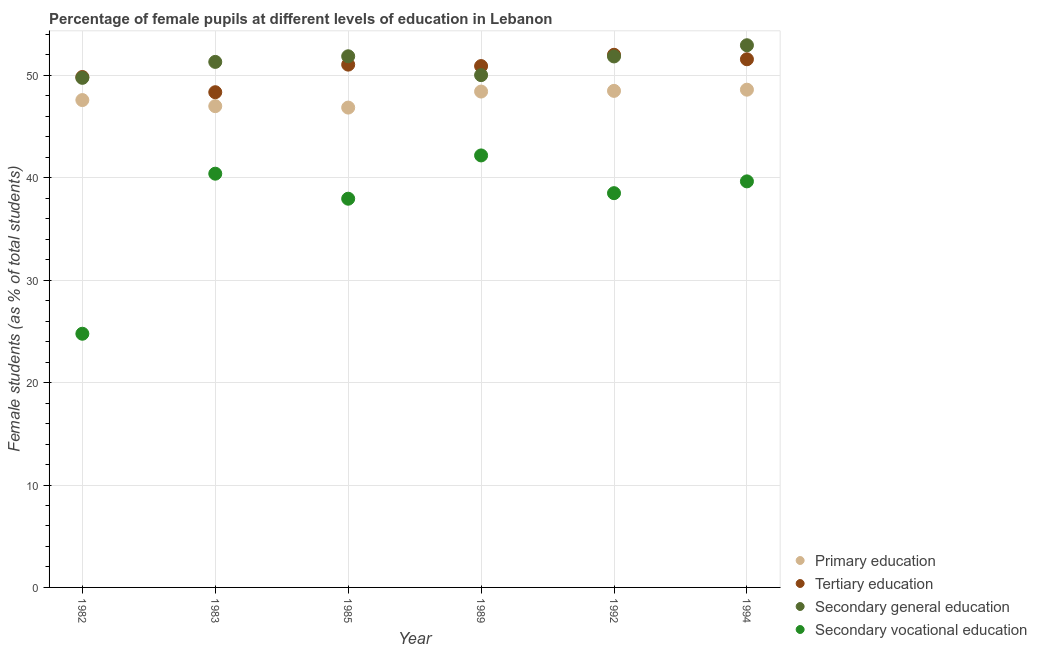What is the percentage of female students in tertiary education in 1992?
Give a very brief answer. 52.01. Across all years, what is the maximum percentage of female students in secondary education?
Your answer should be compact. 52.94. Across all years, what is the minimum percentage of female students in tertiary education?
Give a very brief answer. 48.36. What is the total percentage of female students in secondary vocational education in the graph?
Your answer should be compact. 223.47. What is the difference between the percentage of female students in primary education in 1985 and that in 1992?
Your answer should be very brief. -1.63. What is the difference between the percentage of female students in secondary education in 1983 and the percentage of female students in tertiary education in 1994?
Provide a short and direct response. -0.26. What is the average percentage of female students in tertiary education per year?
Offer a terse response. 50.63. In the year 1992, what is the difference between the percentage of female students in primary education and percentage of female students in secondary education?
Your answer should be compact. -3.36. In how many years, is the percentage of female students in secondary vocational education greater than 22 %?
Give a very brief answer. 6. What is the ratio of the percentage of female students in primary education in 1985 to that in 1989?
Offer a very short reply. 0.97. Is the percentage of female students in tertiary education in 1983 less than that in 1992?
Keep it short and to the point. Yes. Is the difference between the percentage of female students in secondary vocational education in 1983 and 1985 greater than the difference between the percentage of female students in primary education in 1983 and 1985?
Make the answer very short. Yes. What is the difference between the highest and the second highest percentage of female students in secondary education?
Give a very brief answer. 1.08. What is the difference between the highest and the lowest percentage of female students in tertiary education?
Ensure brevity in your answer.  3.66. In how many years, is the percentage of female students in secondary vocational education greater than the average percentage of female students in secondary vocational education taken over all years?
Offer a very short reply. 5. Is it the case that in every year, the sum of the percentage of female students in tertiary education and percentage of female students in secondary vocational education is greater than the sum of percentage of female students in secondary education and percentage of female students in primary education?
Offer a terse response. No. How many dotlines are there?
Keep it short and to the point. 4. How many years are there in the graph?
Provide a short and direct response. 6. Are the values on the major ticks of Y-axis written in scientific E-notation?
Provide a succinct answer. No. Does the graph contain any zero values?
Keep it short and to the point. No. Does the graph contain grids?
Make the answer very short. Yes. Where does the legend appear in the graph?
Your answer should be very brief. Bottom right. What is the title of the graph?
Provide a short and direct response. Percentage of female pupils at different levels of education in Lebanon. What is the label or title of the X-axis?
Make the answer very short. Year. What is the label or title of the Y-axis?
Provide a short and direct response. Female students (as % of total students). What is the Female students (as % of total students) of Primary education in 1982?
Ensure brevity in your answer.  47.59. What is the Female students (as % of total students) in Tertiary education in 1982?
Provide a succinct answer. 49.84. What is the Female students (as % of total students) in Secondary general education in 1982?
Ensure brevity in your answer.  49.76. What is the Female students (as % of total students) of Secondary vocational education in 1982?
Offer a very short reply. 24.77. What is the Female students (as % of total students) of Primary education in 1983?
Provide a succinct answer. 47. What is the Female students (as % of total students) in Tertiary education in 1983?
Keep it short and to the point. 48.36. What is the Female students (as % of total students) in Secondary general education in 1983?
Offer a terse response. 51.32. What is the Female students (as % of total students) of Secondary vocational education in 1983?
Make the answer very short. 40.4. What is the Female students (as % of total students) in Primary education in 1985?
Provide a succinct answer. 46.86. What is the Female students (as % of total students) of Tertiary education in 1985?
Give a very brief answer. 51.05. What is the Female students (as % of total students) in Secondary general education in 1985?
Offer a very short reply. 51.87. What is the Female students (as % of total students) in Secondary vocational education in 1985?
Keep it short and to the point. 37.96. What is the Female students (as % of total students) of Primary education in 1989?
Your answer should be compact. 48.42. What is the Female students (as % of total students) in Tertiary education in 1989?
Provide a short and direct response. 50.91. What is the Female students (as % of total students) of Secondary general education in 1989?
Make the answer very short. 50.03. What is the Female students (as % of total students) of Secondary vocational education in 1989?
Ensure brevity in your answer.  42.18. What is the Female students (as % of total students) in Primary education in 1992?
Give a very brief answer. 48.49. What is the Female students (as % of total students) of Tertiary education in 1992?
Ensure brevity in your answer.  52.01. What is the Female students (as % of total students) of Secondary general education in 1992?
Provide a short and direct response. 51.85. What is the Female students (as % of total students) in Secondary vocational education in 1992?
Offer a very short reply. 38.5. What is the Female students (as % of total students) of Primary education in 1994?
Keep it short and to the point. 48.6. What is the Female students (as % of total students) of Tertiary education in 1994?
Provide a succinct answer. 51.58. What is the Female students (as % of total students) of Secondary general education in 1994?
Your response must be concise. 52.94. What is the Female students (as % of total students) of Secondary vocational education in 1994?
Offer a very short reply. 39.65. Across all years, what is the maximum Female students (as % of total students) of Primary education?
Offer a very short reply. 48.6. Across all years, what is the maximum Female students (as % of total students) of Tertiary education?
Keep it short and to the point. 52.01. Across all years, what is the maximum Female students (as % of total students) in Secondary general education?
Provide a short and direct response. 52.94. Across all years, what is the maximum Female students (as % of total students) of Secondary vocational education?
Provide a short and direct response. 42.18. Across all years, what is the minimum Female students (as % of total students) of Primary education?
Offer a very short reply. 46.86. Across all years, what is the minimum Female students (as % of total students) of Tertiary education?
Your answer should be very brief. 48.36. Across all years, what is the minimum Female students (as % of total students) in Secondary general education?
Make the answer very short. 49.76. Across all years, what is the minimum Female students (as % of total students) in Secondary vocational education?
Your response must be concise. 24.77. What is the total Female students (as % of total students) of Primary education in the graph?
Your answer should be compact. 286.96. What is the total Female students (as % of total students) in Tertiary education in the graph?
Offer a very short reply. 303.75. What is the total Female students (as % of total students) of Secondary general education in the graph?
Provide a short and direct response. 307.77. What is the total Female students (as % of total students) in Secondary vocational education in the graph?
Make the answer very short. 223.47. What is the difference between the Female students (as % of total students) in Primary education in 1982 and that in 1983?
Keep it short and to the point. 0.59. What is the difference between the Female students (as % of total students) of Tertiary education in 1982 and that in 1983?
Provide a short and direct response. 1.49. What is the difference between the Female students (as % of total students) in Secondary general education in 1982 and that in 1983?
Provide a short and direct response. -1.56. What is the difference between the Female students (as % of total students) of Secondary vocational education in 1982 and that in 1983?
Give a very brief answer. -15.63. What is the difference between the Female students (as % of total students) of Primary education in 1982 and that in 1985?
Give a very brief answer. 0.73. What is the difference between the Female students (as % of total students) in Tertiary education in 1982 and that in 1985?
Offer a very short reply. -1.21. What is the difference between the Female students (as % of total students) in Secondary general education in 1982 and that in 1985?
Offer a terse response. -2.11. What is the difference between the Female students (as % of total students) in Secondary vocational education in 1982 and that in 1985?
Ensure brevity in your answer.  -13.19. What is the difference between the Female students (as % of total students) in Primary education in 1982 and that in 1989?
Keep it short and to the point. -0.83. What is the difference between the Female students (as % of total students) of Tertiary education in 1982 and that in 1989?
Provide a short and direct response. -1.07. What is the difference between the Female students (as % of total students) in Secondary general education in 1982 and that in 1989?
Keep it short and to the point. -0.26. What is the difference between the Female students (as % of total students) in Secondary vocational education in 1982 and that in 1989?
Make the answer very short. -17.41. What is the difference between the Female students (as % of total students) in Primary education in 1982 and that in 1992?
Offer a terse response. -0.9. What is the difference between the Female students (as % of total students) of Tertiary education in 1982 and that in 1992?
Make the answer very short. -2.17. What is the difference between the Female students (as % of total students) in Secondary general education in 1982 and that in 1992?
Keep it short and to the point. -2.09. What is the difference between the Female students (as % of total students) of Secondary vocational education in 1982 and that in 1992?
Provide a succinct answer. -13.73. What is the difference between the Female students (as % of total students) in Primary education in 1982 and that in 1994?
Ensure brevity in your answer.  -1.01. What is the difference between the Female students (as % of total students) in Tertiary education in 1982 and that in 1994?
Your response must be concise. -1.73. What is the difference between the Female students (as % of total students) of Secondary general education in 1982 and that in 1994?
Provide a succinct answer. -3.18. What is the difference between the Female students (as % of total students) in Secondary vocational education in 1982 and that in 1994?
Your answer should be very brief. -14.88. What is the difference between the Female students (as % of total students) of Primary education in 1983 and that in 1985?
Your answer should be very brief. 0.14. What is the difference between the Female students (as % of total students) of Tertiary education in 1983 and that in 1985?
Provide a short and direct response. -2.69. What is the difference between the Female students (as % of total students) in Secondary general education in 1983 and that in 1985?
Provide a short and direct response. -0.55. What is the difference between the Female students (as % of total students) in Secondary vocational education in 1983 and that in 1985?
Your response must be concise. 2.44. What is the difference between the Female students (as % of total students) of Primary education in 1983 and that in 1989?
Offer a terse response. -1.43. What is the difference between the Female students (as % of total students) of Tertiary education in 1983 and that in 1989?
Offer a terse response. -2.55. What is the difference between the Female students (as % of total students) in Secondary general education in 1983 and that in 1989?
Make the answer very short. 1.29. What is the difference between the Female students (as % of total students) in Secondary vocational education in 1983 and that in 1989?
Make the answer very short. -1.78. What is the difference between the Female students (as % of total students) in Primary education in 1983 and that in 1992?
Make the answer very short. -1.49. What is the difference between the Female students (as % of total students) of Tertiary education in 1983 and that in 1992?
Give a very brief answer. -3.66. What is the difference between the Female students (as % of total students) of Secondary general education in 1983 and that in 1992?
Provide a short and direct response. -0.53. What is the difference between the Female students (as % of total students) in Secondary vocational education in 1983 and that in 1992?
Provide a short and direct response. 1.9. What is the difference between the Female students (as % of total students) of Primary education in 1983 and that in 1994?
Offer a terse response. -1.61. What is the difference between the Female students (as % of total students) in Tertiary education in 1983 and that in 1994?
Make the answer very short. -3.22. What is the difference between the Female students (as % of total students) in Secondary general education in 1983 and that in 1994?
Give a very brief answer. -1.63. What is the difference between the Female students (as % of total students) of Secondary vocational education in 1983 and that in 1994?
Your response must be concise. 0.75. What is the difference between the Female students (as % of total students) in Primary education in 1985 and that in 1989?
Your answer should be compact. -1.57. What is the difference between the Female students (as % of total students) of Tertiary education in 1985 and that in 1989?
Offer a terse response. 0.14. What is the difference between the Female students (as % of total students) of Secondary general education in 1985 and that in 1989?
Provide a succinct answer. 1.84. What is the difference between the Female students (as % of total students) of Secondary vocational education in 1985 and that in 1989?
Provide a short and direct response. -4.23. What is the difference between the Female students (as % of total students) of Primary education in 1985 and that in 1992?
Offer a very short reply. -1.63. What is the difference between the Female students (as % of total students) of Tertiary education in 1985 and that in 1992?
Offer a very short reply. -0.96. What is the difference between the Female students (as % of total students) of Secondary general education in 1985 and that in 1992?
Keep it short and to the point. 0.02. What is the difference between the Female students (as % of total students) in Secondary vocational education in 1985 and that in 1992?
Ensure brevity in your answer.  -0.54. What is the difference between the Female students (as % of total students) of Primary education in 1985 and that in 1994?
Offer a terse response. -1.75. What is the difference between the Female students (as % of total students) of Tertiary education in 1985 and that in 1994?
Provide a succinct answer. -0.52. What is the difference between the Female students (as % of total students) of Secondary general education in 1985 and that in 1994?
Your response must be concise. -1.08. What is the difference between the Female students (as % of total students) of Secondary vocational education in 1985 and that in 1994?
Give a very brief answer. -1.69. What is the difference between the Female students (as % of total students) of Primary education in 1989 and that in 1992?
Provide a short and direct response. -0.07. What is the difference between the Female students (as % of total students) in Tertiary education in 1989 and that in 1992?
Make the answer very short. -1.1. What is the difference between the Female students (as % of total students) of Secondary general education in 1989 and that in 1992?
Your response must be concise. -1.83. What is the difference between the Female students (as % of total students) of Secondary vocational education in 1989 and that in 1992?
Your response must be concise. 3.69. What is the difference between the Female students (as % of total students) in Primary education in 1989 and that in 1994?
Provide a short and direct response. -0.18. What is the difference between the Female students (as % of total students) in Tertiary education in 1989 and that in 1994?
Provide a short and direct response. -0.67. What is the difference between the Female students (as % of total students) of Secondary general education in 1989 and that in 1994?
Provide a succinct answer. -2.92. What is the difference between the Female students (as % of total students) of Secondary vocational education in 1989 and that in 1994?
Make the answer very short. 2.53. What is the difference between the Female students (as % of total students) in Primary education in 1992 and that in 1994?
Keep it short and to the point. -0.12. What is the difference between the Female students (as % of total students) of Tertiary education in 1992 and that in 1994?
Provide a succinct answer. 0.44. What is the difference between the Female students (as % of total students) of Secondary general education in 1992 and that in 1994?
Your answer should be very brief. -1.09. What is the difference between the Female students (as % of total students) of Secondary vocational education in 1992 and that in 1994?
Offer a terse response. -1.15. What is the difference between the Female students (as % of total students) in Primary education in 1982 and the Female students (as % of total students) in Tertiary education in 1983?
Your answer should be very brief. -0.77. What is the difference between the Female students (as % of total students) in Primary education in 1982 and the Female students (as % of total students) in Secondary general education in 1983?
Make the answer very short. -3.73. What is the difference between the Female students (as % of total students) of Primary education in 1982 and the Female students (as % of total students) of Secondary vocational education in 1983?
Your response must be concise. 7.19. What is the difference between the Female students (as % of total students) in Tertiary education in 1982 and the Female students (as % of total students) in Secondary general education in 1983?
Your answer should be very brief. -1.47. What is the difference between the Female students (as % of total students) in Tertiary education in 1982 and the Female students (as % of total students) in Secondary vocational education in 1983?
Provide a short and direct response. 9.44. What is the difference between the Female students (as % of total students) in Secondary general education in 1982 and the Female students (as % of total students) in Secondary vocational education in 1983?
Offer a terse response. 9.36. What is the difference between the Female students (as % of total students) of Primary education in 1982 and the Female students (as % of total students) of Tertiary education in 1985?
Your response must be concise. -3.46. What is the difference between the Female students (as % of total students) of Primary education in 1982 and the Female students (as % of total students) of Secondary general education in 1985?
Your answer should be very brief. -4.28. What is the difference between the Female students (as % of total students) of Primary education in 1982 and the Female students (as % of total students) of Secondary vocational education in 1985?
Give a very brief answer. 9.63. What is the difference between the Female students (as % of total students) in Tertiary education in 1982 and the Female students (as % of total students) in Secondary general education in 1985?
Your response must be concise. -2.02. What is the difference between the Female students (as % of total students) in Tertiary education in 1982 and the Female students (as % of total students) in Secondary vocational education in 1985?
Keep it short and to the point. 11.89. What is the difference between the Female students (as % of total students) of Secondary general education in 1982 and the Female students (as % of total students) of Secondary vocational education in 1985?
Your answer should be very brief. 11.8. What is the difference between the Female students (as % of total students) in Primary education in 1982 and the Female students (as % of total students) in Tertiary education in 1989?
Your response must be concise. -3.32. What is the difference between the Female students (as % of total students) of Primary education in 1982 and the Female students (as % of total students) of Secondary general education in 1989?
Make the answer very short. -2.43. What is the difference between the Female students (as % of total students) of Primary education in 1982 and the Female students (as % of total students) of Secondary vocational education in 1989?
Offer a terse response. 5.41. What is the difference between the Female students (as % of total students) of Tertiary education in 1982 and the Female students (as % of total students) of Secondary general education in 1989?
Your answer should be very brief. -0.18. What is the difference between the Female students (as % of total students) in Tertiary education in 1982 and the Female students (as % of total students) in Secondary vocational education in 1989?
Make the answer very short. 7.66. What is the difference between the Female students (as % of total students) in Secondary general education in 1982 and the Female students (as % of total students) in Secondary vocational education in 1989?
Make the answer very short. 7.58. What is the difference between the Female students (as % of total students) of Primary education in 1982 and the Female students (as % of total students) of Tertiary education in 1992?
Provide a succinct answer. -4.42. What is the difference between the Female students (as % of total students) in Primary education in 1982 and the Female students (as % of total students) in Secondary general education in 1992?
Keep it short and to the point. -4.26. What is the difference between the Female students (as % of total students) in Primary education in 1982 and the Female students (as % of total students) in Secondary vocational education in 1992?
Make the answer very short. 9.09. What is the difference between the Female students (as % of total students) in Tertiary education in 1982 and the Female students (as % of total students) in Secondary general education in 1992?
Ensure brevity in your answer.  -2.01. What is the difference between the Female students (as % of total students) in Tertiary education in 1982 and the Female students (as % of total students) in Secondary vocational education in 1992?
Provide a succinct answer. 11.34. What is the difference between the Female students (as % of total students) of Secondary general education in 1982 and the Female students (as % of total students) of Secondary vocational education in 1992?
Ensure brevity in your answer.  11.26. What is the difference between the Female students (as % of total students) of Primary education in 1982 and the Female students (as % of total students) of Tertiary education in 1994?
Your answer should be compact. -3.99. What is the difference between the Female students (as % of total students) of Primary education in 1982 and the Female students (as % of total students) of Secondary general education in 1994?
Ensure brevity in your answer.  -5.35. What is the difference between the Female students (as % of total students) in Primary education in 1982 and the Female students (as % of total students) in Secondary vocational education in 1994?
Make the answer very short. 7.94. What is the difference between the Female students (as % of total students) in Tertiary education in 1982 and the Female students (as % of total students) in Secondary general education in 1994?
Provide a succinct answer. -3.1. What is the difference between the Female students (as % of total students) in Tertiary education in 1982 and the Female students (as % of total students) in Secondary vocational education in 1994?
Keep it short and to the point. 10.19. What is the difference between the Female students (as % of total students) in Secondary general education in 1982 and the Female students (as % of total students) in Secondary vocational education in 1994?
Provide a short and direct response. 10.11. What is the difference between the Female students (as % of total students) of Primary education in 1983 and the Female students (as % of total students) of Tertiary education in 1985?
Ensure brevity in your answer.  -4.06. What is the difference between the Female students (as % of total students) of Primary education in 1983 and the Female students (as % of total students) of Secondary general education in 1985?
Provide a short and direct response. -4.87. What is the difference between the Female students (as % of total students) of Primary education in 1983 and the Female students (as % of total students) of Secondary vocational education in 1985?
Ensure brevity in your answer.  9.04. What is the difference between the Female students (as % of total students) of Tertiary education in 1983 and the Female students (as % of total students) of Secondary general education in 1985?
Provide a short and direct response. -3.51. What is the difference between the Female students (as % of total students) in Tertiary education in 1983 and the Female students (as % of total students) in Secondary vocational education in 1985?
Offer a terse response. 10.4. What is the difference between the Female students (as % of total students) in Secondary general education in 1983 and the Female students (as % of total students) in Secondary vocational education in 1985?
Provide a succinct answer. 13.36. What is the difference between the Female students (as % of total students) of Primary education in 1983 and the Female students (as % of total students) of Tertiary education in 1989?
Offer a very short reply. -3.91. What is the difference between the Female students (as % of total students) of Primary education in 1983 and the Female students (as % of total students) of Secondary general education in 1989?
Provide a short and direct response. -3.03. What is the difference between the Female students (as % of total students) in Primary education in 1983 and the Female students (as % of total students) in Secondary vocational education in 1989?
Your response must be concise. 4.81. What is the difference between the Female students (as % of total students) in Tertiary education in 1983 and the Female students (as % of total students) in Secondary general education in 1989?
Provide a short and direct response. -1.67. What is the difference between the Female students (as % of total students) of Tertiary education in 1983 and the Female students (as % of total students) of Secondary vocational education in 1989?
Make the answer very short. 6.17. What is the difference between the Female students (as % of total students) of Secondary general education in 1983 and the Female students (as % of total students) of Secondary vocational education in 1989?
Offer a terse response. 9.13. What is the difference between the Female students (as % of total students) of Primary education in 1983 and the Female students (as % of total students) of Tertiary education in 1992?
Your answer should be very brief. -5.02. What is the difference between the Female students (as % of total students) of Primary education in 1983 and the Female students (as % of total students) of Secondary general education in 1992?
Offer a terse response. -4.85. What is the difference between the Female students (as % of total students) in Primary education in 1983 and the Female students (as % of total students) in Secondary vocational education in 1992?
Keep it short and to the point. 8.5. What is the difference between the Female students (as % of total students) in Tertiary education in 1983 and the Female students (as % of total students) in Secondary general education in 1992?
Offer a very short reply. -3.49. What is the difference between the Female students (as % of total students) of Tertiary education in 1983 and the Female students (as % of total students) of Secondary vocational education in 1992?
Give a very brief answer. 9.86. What is the difference between the Female students (as % of total students) of Secondary general education in 1983 and the Female students (as % of total students) of Secondary vocational education in 1992?
Keep it short and to the point. 12.82. What is the difference between the Female students (as % of total students) of Primary education in 1983 and the Female students (as % of total students) of Tertiary education in 1994?
Provide a short and direct response. -4.58. What is the difference between the Female students (as % of total students) of Primary education in 1983 and the Female students (as % of total students) of Secondary general education in 1994?
Ensure brevity in your answer.  -5.95. What is the difference between the Female students (as % of total students) in Primary education in 1983 and the Female students (as % of total students) in Secondary vocational education in 1994?
Provide a succinct answer. 7.34. What is the difference between the Female students (as % of total students) in Tertiary education in 1983 and the Female students (as % of total students) in Secondary general education in 1994?
Provide a short and direct response. -4.59. What is the difference between the Female students (as % of total students) of Tertiary education in 1983 and the Female students (as % of total students) of Secondary vocational education in 1994?
Offer a terse response. 8.71. What is the difference between the Female students (as % of total students) in Secondary general education in 1983 and the Female students (as % of total students) in Secondary vocational education in 1994?
Give a very brief answer. 11.67. What is the difference between the Female students (as % of total students) in Primary education in 1985 and the Female students (as % of total students) in Tertiary education in 1989?
Give a very brief answer. -4.05. What is the difference between the Female students (as % of total students) in Primary education in 1985 and the Female students (as % of total students) in Secondary general education in 1989?
Offer a terse response. -3.17. What is the difference between the Female students (as % of total students) in Primary education in 1985 and the Female students (as % of total students) in Secondary vocational education in 1989?
Give a very brief answer. 4.67. What is the difference between the Female students (as % of total students) in Tertiary education in 1985 and the Female students (as % of total students) in Secondary general education in 1989?
Give a very brief answer. 1.03. What is the difference between the Female students (as % of total students) in Tertiary education in 1985 and the Female students (as % of total students) in Secondary vocational education in 1989?
Provide a succinct answer. 8.87. What is the difference between the Female students (as % of total students) in Secondary general education in 1985 and the Female students (as % of total students) in Secondary vocational education in 1989?
Ensure brevity in your answer.  9.68. What is the difference between the Female students (as % of total students) in Primary education in 1985 and the Female students (as % of total students) in Tertiary education in 1992?
Your response must be concise. -5.16. What is the difference between the Female students (as % of total students) in Primary education in 1985 and the Female students (as % of total students) in Secondary general education in 1992?
Provide a succinct answer. -4.99. What is the difference between the Female students (as % of total students) of Primary education in 1985 and the Female students (as % of total students) of Secondary vocational education in 1992?
Give a very brief answer. 8.36. What is the difference between the Female students (as % of total students) of Tertiary education in 1985 and the Female students (as % of total students) of Secondary general education in 1992?
Your response must be concise. -0.8. What is the difference between the Female students (as % of total students) of Tertiary education in 1985 and the Female students (as % of total students) of Secondary vocational education in 1992?
Ensure brevity in your answer.  12.55. What is the difference between the Female students (as % of total students) in Secondary general education in 1985 and the Female students (as % of total students) in Secondary vocational education in 1992?
Your response must be concise. 13.37. What is the difference between the Female students (as % of total students) in Primary education in 1985 and the Female students (as % of total students) in Tertiary education in 1994?
Keep it short and to the point. -4.72. What is the difference between the Female students (as % of total students) in Primary education in 1985 and the Female students (as % of total students) in Secondary general education in 1994?
Provide a short and direct response. -6.09. What is the difference between the Female students (as % of total students) in Primary education in 1985 and the Female students (as % of total students) in Secondary vocational education in 1994?
Ensure brevity in your answer.  7.21. What is the difference between the Female students (as % of total students) in Tertiary education in 1985 and the Female students (as % of total students) in Secondary general education in 1994?
Your response must be concise. -1.89. What is the difference between the Female students (as % of total students) in Tertiary education in 1985 and the Female students (as % of total students) in Secondary vocational education in 1994?
Provide a succinct answer. 11.4. What is the difference between the Female students (as % of total students) in Secondary general education in 1985 and the Female students (as % of total students) in Secondary vocational education in 1994?
Ensure brevity in your answer.  12.22. What is the difference between the Female students (as % of total students) of Primary education in 1989 and the Female students (as % of total students) of Tertiary education in 1992?
Your answer should be very brief. -3.59. What is the difference between the Female students (as % of total students) in Primary education in 1989 and the Female students (as % of total students) in Secondary general education in 1992?
Offer a terse response. -3.43. What is the difference between the Female students (as % of total students) in Primary education in 1989 and the Female students (as % of total students) in Secondary vocational education in 1992?
Give a very brief answer. 9.92. What is the difference between the Female students (as % of total students) of Tertiary education in 1989 and the Female students (as % of total students) of Secondary general education in 1992?
Offer a terse response. -0.94. What is the difference between the Female students (as % of total students) of Tertiary education in 1989 and the Female students (as % of total students) of Secondary vocational education in 1992?
Make the answer very short. 12.41. What is the difference between the Female students (as % of total students) of Secondary general education in 1989 and the Female students (as % of total students) of Secondary vocational education in 1992?
Provide a succinct answer. 11.53. What is the difference between the Female students (as % of total students) of Primary education in 1989 and the Female students (as % of total students) of Tertiary education in 1994?
Your response must be concise. -3.15. What is the difference between the Female students (as % of total students) in Primary education in 1989 and the Female students (as % of total students) in Secondary general education in 1994?
Offer a very short reply. -4.52. What is the difference between the Female students (as % of total students) of Primary education in 1989 and the Female students (as % of total students) of Secondary vocational education in 1994?
Your response must be concise. 8.77. What is the difference between the Female students (as % of total students) in Tertiary education in 1989 and the Female students (as % of total students) in Secondary general education in 1994?
Give a very brief answer. -2.03. What is the difference between the Female students (as % of total students) in Tertiary education in 1989 and the Female students (as % of total students) in Secondary vocational education in 1994?
Your answer should be very brief. 11.26. What is the difference between the Female students (as % of total students) of Secondary general education in 1989 and the Female students (as % of total students) of Secondary vocational education in 1994?
Your answer should be compact. 10.37. What is the difference between the Female students (as % of total students) in Primary education in 1992 and the Female students (as % of total students) in Tertiary education in 1994?
Provide a short and direct response. -3.09. What is the difference between the Female students (as % of total students) in Primary education in 1992 and the Female students (as % of total students) in Secondary general education in 1994?
Your answer should be compact. -4.46. What is the difference between the Female students (as % of total students) in Primary education in 1992 and the Female students (as % of total students) in Secondary vocational education in 1994?
Offer a very short reply. 8.84. What is the difference between the Female students (as % of total students) of Tertiary education in 1992 and the Female students (as % of total students) of Secondary general education in 1994?
Offer a very short reply. -0.93. What is the difference between the Female students (as % of total students) in Tertiary education in 1992 and the Female students (as % of total students) in Secondary vocational education in 1994?
Your answer should be very brief. 12.36. What is the difference between the Female students (as % of total students) of Secondary general education in 1992 and the Female students (as % of total students) of Secondary vocational education in 1994?
Make the answer very short. 12.2. What is the average Female students (as % of total students) of Primary education per year?
Provide a short and direct response. 47.83. What is the average Female students (as % of total students) in Tertiary education per year?
Make the answer very short. 50.63. What is the average Female students (as % of total students) in Secondary general education per year?
Ensure brevity in your answer.  51.29. What is the average Female students (as % of total students) in Secondary vocational education per year?
Make the answer very short. 37.24. In the year 1982, what is the difference between the Female students (as % of total students) in Primary education and Female students (as % of total students) in Tertiary education?
Keep it short and to the point. -2.25. In the year 1982, what is the difference between the Female students (as % of total students) in Primary education and Female students (as % of total students) in Secondary general education?
Make the answer very short. -2.17. In the year 1982, what is the difference between the Female students (as % of total students) of Primary education and Female students (as % of total students) of Secondary vocational education?
Provide a short and direct response. 22.82. In the year 1982, what is the difference between the Female students (as % of total students) in Tertiary education and Female students (as % of total students) in Secondary general education?
Your response must be concise. 0.08. In the year 1982, what is the difference between the Female students (as % of total students) in Tertiary education and Female students (as % of total students) in Secondary vocational education?
Give a very brief answer. 25.07. In the year 1982, what is the difference between the Female students (as % of total students) of Secondary general education and Female students (as % of total students) of Secondary vocational education?
Offer a terse response. 24.99. In the year 1983, what is the difference between the Female students (as % of total students) of Primary education and Female students (as % of total students) of Tertiary education?
Provide a short and direct response. -1.36. In the year 1983, what is the difference between the Female students (as % of total students) in Primary education and Female students (as % of total students) in Secondary general education?
Ensure brevity in your answer.  -4.32. In the year 1983, what is the difference between the Female students (as % of total students) in Primary education and Female students (as % of total students) in Secondary vocational education?
Ensure brevity in your answer.  6.59. In the year 1983, what is the difference between the Female students (as % of total students) of Tertiary education and Female students (as % of total students) of Secondary general education?
Give a very brief answer. -2.96. In the year 1983, what is the difference between the Female students (as % of total students) of Tertiary education and Female students (as % of total students) of Secondary vocational education?
Offer a very short reply. 7.96. In the year 1983, what is the difference between the Female students (as % of total students) in Secondary general education and Female students (as % of total students) in Secondary vocational education?
Provide a succinct answer. 10.92. In the year 1985, what is the difference between the Female students (as % of total students) in Primary education and Female students (as % of total students) in Tertiary education?
Provide a succinct answer. -4.19. In the year 1985, what is the difference between the Female students (as % of total students) of Primary education and Female students (as % of total students) of Secondary general education?
Provide a short and direct response. -5.01. In the year 1985, what is the difference between the Female students (as % of total students) of Primary education and Female students (as % of total students) of Secondary vocational education?
Offer a very short reply. 8.9. In the year 1985, what is the difference between the Female students (as % of total students) in Tertiary education and Female students (as % of total students) in Secondary general education?
Your answer should be very brief. -0.82. In the year 1985, what is the difference between the Female students (as % of total students) in Tertiary education and Female students (as % of total students) in Secondary vocational education?
Offer a very short reply. 13.09. In the year 1985, what is the difference between the Female students (as % of total students) of Secondary general education and Female students (as % of total students) of Secondary vocational education?
Your response must be concise. 13.91. In the year 1989, what is the difference between the Female students (as % of total students) of Primary education and Female students (as % of total students) of Tertiary education?
Offer a terse response. -2.49. In the year 1989, what is the difference between the Female students (as % of total students) of Primary education and Female students (as % of total students) of Secondary general education?
Ensure brevity in your answer.  -1.6. In the year 1989, what is the difference between the Female students (as % of total students) in Primary education and Female students (as % of total students) in Secondary vocational education?
Provide a short and direct response. 6.24. In the year 1989, what is the difference between the Female students (as % of total students) of Tertiary education and Female students (as % of total students) of Secondary general education?
Provide a succinct answer. 0.89. In the year 1989, what is the difference between the Female students (as % of total students) in Tertiary education and Female students (as % of total students) in Secondary vocational education?
Give a very brief answer. 8.73. In the year 1989, what is the difference between the Female students (as % of total students) of Secondary general education and Female students (as % of total students) of Secondary vocational education?
Your response must be concise. 7.84. In the year 1992, what is the difference between the Female students (as % of total students) of Primary education and Female students (as % of total students) of Tertiary education?
Make the answer very short. -3.52. In the year 1992, what is the difference between the Female students (as % of total students) of Primary education and Female students (as % of total students) of Secondary general education?
Provide a succinct answer. -3.36. In the year 1992, what is the difference between the Female students (as % of total students) of Primary education and Female students (as % of total students) of Secondary vocational education?
Your answer should be compact. 9.99. In the year 1992, what is the difference between the Female students (as % of total students) of Tertiary education and Female students (as % of total students) of Secondary general education?
Provide a succinct answer. 0.16. In the year 1992, what is the difference between the Female students (as % of total students) in Tertiary education and Female students (as % of total students) in Secondary vocational education?
Provide a short and direct response. 13.51. In the year 1992, what is the difference between the Female students (as % of total students) of Secondary general education and Female students (as % of total students) of Secondary vocational education?
Ensure brevity in your answer.  13.35. In the year 1994, what is the difference between the Female students (as % of total students) in Primary education and Female students (as % of total students) in Tertiary education?
Your response must be concise. -2.97. In the year 1994, what is the difference between the Female students (as % of total students) of Primary education and Female students (as % of total students) of Secondary general education?
Give a very brief answer. -4.34. In the year 1994, what is the difference between the Female students (as % of total students) of Primary education and Female students (as % of total students) of Secondary vocational education?
Your answer should be compact. 8.95. In the year 1994, what is the difference between the Female students (as % of total students) in Tertiary education and Female students (as % of total students) in Secondary general education?
Your answer should be compact. -1.37. In the year 1994, what is the difference between the Female students (as % of total students) in Tertiary education and Female students (as % of total students) in Secondary vocational education?
Offer a terse response. 11.92. In the year 1994, what is the difference between the Female students (as % of total students) of Secondary general education and Female students (as % of total students) of Secondary vocational education?
Ensure brevity in your answer.  13.29. What is the ratio of the Female students (as % of total students) of Primary education in 1982 to that in 1983?
Make the answer very short. 1.01. What is the ratio of the Female students (as % of total students) of Tertiary education in 1982 to that in 1983?
Provide a succinct answer. 1.03. What is the ratio of the Female students (as % of total students) in Secondary general education in 1982 to that in 1983?
Keep it short and to the point. 0.97. What is the ratio of the Female students (as % of total students) in Secondary vocational education in 1982 to that in 1983?
Make the answer very short. 0.61. What is the ratio of the Female students (as % of total students) of Primary education in 1982 to that in 1985?
Your answer should be compact. 1.02. What is the ratio of the Female students (as % of total students) of Tertiary education in 1982 to that in 1985?
Make the answer very short. 0.98. What is the ratio of the Female students (as % of total students) of Secondary general education in 1982 to that in 1985?
Provide a succinct answer. 0.96. What is the ratio of the Female students (as % of total students) in Secondary vocational education in 1982 to that in 1985?
Your answer should be compact. 0.65. What is the ratio of the Female students (as % of total students) in Primary education in 1982 to that in 1989?
Keep it short and to the point. 0.98. What is the ratio of the Female students (as % of total students) in Secondary vocational education in 1982 to that in 1989?
Make the answer very short. 0.59. What is the ratio of the Female students (as % of total students) in Primary education in 1982 to that in 1992?
Your answer should be very brief. 0.98. What is the ratio of the Female students (as % of total students) of Secondary general education in 1982 to that in 1992?
Give a very brief answer. 0.96. What is the ratio of the Female students (as % of total students) of Secondary vocational education in 1982 to that in 1992?
Give a very brief answer. 0.64. What is the ratio of the Female students (as % of total students) in Primary education in 1982 to that in 1994?
Keep it short and to the point. 0.98. What is the ratio of the Female students (as % of total students) of Tertiary education in 1982 to that in 1994?
Provide a short and direct response. 0.97. What is the ratio of the Female students (as % of total students) of Secondary general education in 1982 to that in 1994?
Provide a succinct answer. 0.94. What is the ratio of the Female students (as % of total students) of Secondary vocational education in 1982 to that in 1994?
Provide a short and direct response. 0.62. What is the ratio of the Female students (as % of total students) in Tertiary education in 1983 to that in 1985?
Your answer should be compact. 0.95. What is the ratio of the Female students (as % of total students) of Secondary vocational education in 1983 to that in 1985?
Your answer should be very brief. 1.06. What is the ratio of the Female students (as % of total students) in Primary education in 1983 to that in 1989?
Your response must be concise. 0.97. What is the ratio of the Female students (as % of total students) of Tertiary education in 1983 to that in 1989?
Your response must be concise. 0.95. What is the ratio of the Female students (as % of total students) of Secondary general education in 1983 to that in 1989?
Offer a terse response. 1.03. What is the ratio of the Female students (as % of total students) of Secondary vocational education in 1983 to that in 1989?
Your response must be concise. 0.96. What is the ratio of the Female students (as % of total students) in Primary education in 1983 to that in 1992?
Make the answer very short. 0.97. What is the ratio of the Female students (as % of total students) of Tertiary education in 1983 to that in 1992?
Give a very brief answer. 0.93. What is the ratio of the Female students (as % of total students) in Secondary general education in 1983 to that in 1992?
Ensure brevity in your answer.  0.99. What is the ratio of the Female students (as % of total students) in Secondary vocational education in 1983 to that in 1992?
Provide a succinct answer. 1.05. What is the ratio of the Female students (as % of total students) of Primary education in 1983 to that in 1994?
Keep it short and to the point. 0.97. What is the ratio of the Female students (as % of total students) of Tertiary education in 1983 to that in 1994?
Your answer should be compact. 0.94. What is the ratio of the Female students (as % of total students) in Secondary general education in 1983 to that in 1994?
Make the answer very short. 0.97. What is the ratio of the Female students (as % of total students) in Secondary vocational education in 1983 to that in 1994?
Your answer should be very brief. 1.02. What is the ratio of the Female students (as % of total students) of Primary education in 1985 to that in 1989?
Your answer should be compact. 0.97. What is the ratio of the Female students (as % of total students) of Secondary general education in 1985 to that in 1989?
Your response must be concise. 1.04. What is the ratio of the Female students (as % of total students) of Secondary vocational education in 1985 to that in 1989?
Offer a very short reply. 0.9. What is the ratio of the Female students (as % of total students) of Primary education in 1985 to that in 1992?
Make the answer very short. 0.97. What is the ratio of the Female students (as % of total students) in Tertiary education in 1985 to that in 1992?
Keep it short and to the point. 0.98. What is the ratio of the Female students (as % of total students) in Secondary general education in 1985 to that in 1992?
Your answer should be very brief. 1. What is the ratio of the Female students (as % of total students) in Secondary vocational education in 1985 to that in 1992?
Offer a very short reply. 0.99. What is the ratio of the Female students (as % of total students) in Tertiary education in 1985 to that in 1994?
Ensure brevity in your answer.  0.99. What is the ratio of the Female students (as % of total students) of Secondary general education in 1985 to that in 1994?
Your answer should be very brief. 0.98. What is the ratio of the Female students (as % of total students) in Secondary vocational education in 1985 to that in 1994?
Offer a very short reply. 0.96. What is the ratio of the Female students (as % of total students) of Primary education in 1989 to that in 1992?
Your answer should be very brief. 1. What is the ratio of the Female students (as % of total students) in Tertiary education in 1989 to that in 1992?
Keep it short and to the point. 0.98. What is the ratio of the Female students (as % of total students) in Secondary general education in 1989 to that in 1992?
Offer a terse response. 0.96. What is the ratio of the Female students (as % of total students) in Secondary vocational education in 1989 to that in 1992?
Your answer should be compact. 1.1. What is the ratio of the Female students (as % of total students) of Primary education in 1989 to that in 1994?
Keep it short and to the point. 1. What is the ratio of the Female students (as % of total students) of Tertiary education in 1989 to that in 1994?
Offer a very short reply. 0.99. What is the ratio of the Female students (as % of total students) of Secondary general education in 1989 to that in 1994?
Make the answer very short. 0.94. What is the ratio of the Female students (as % of total students) of Secondary vocational education in 1989 to that in 1994?
Your answer should be very brief. 1.06. What is the ratio of the Female students (as % of total students) of Tertiary education in 1992 to that in 1994?
Offer a terse response. 1.01. What is the ratio of the Female students (as % of total students) in Secondary general education in 1992 to that in 1994?
Offer a very short reply. 0.98. What is the ratio of the Female students (as % of total students) in Secondary vocational education in 1992 to that in 1994?
Offer a terse response. 0.97. What is the difference between the highest and the second highest Female students (as % of total students) of Primary education?
Your response must be concise. 0.12. What is the difference between the highest and the second highest Female students (as % of total students) in Tertiary education?
Keep it short and to the point. 0.44. What is the difference between the highest and the second highest Female students (as % of total students) of Secondary general education?
Make the answer very short. 1.08. What is the difference between the highest and the second highest Female students (as % of total students) of Secondary vocational education?
Your response must be concise. 1.78. What is the difference between the highest and the lowest Female students (as % of total students) in Primary education?
Offer a very short reply. 1.75. What is the difference between the highest and the lowest Female students (as % of total students) of Tertiary education?
Keep it short and to the point. 3.66. What is the difference between the highest and the lowest Female students (as % of total students) of Secondary general education?
Give a very brief answer. 3.18. What is the difference between the highest and the lowest Female students (as % of total students) in Secondary vocational education?
Ensure brevity in your answer.  17.41. 